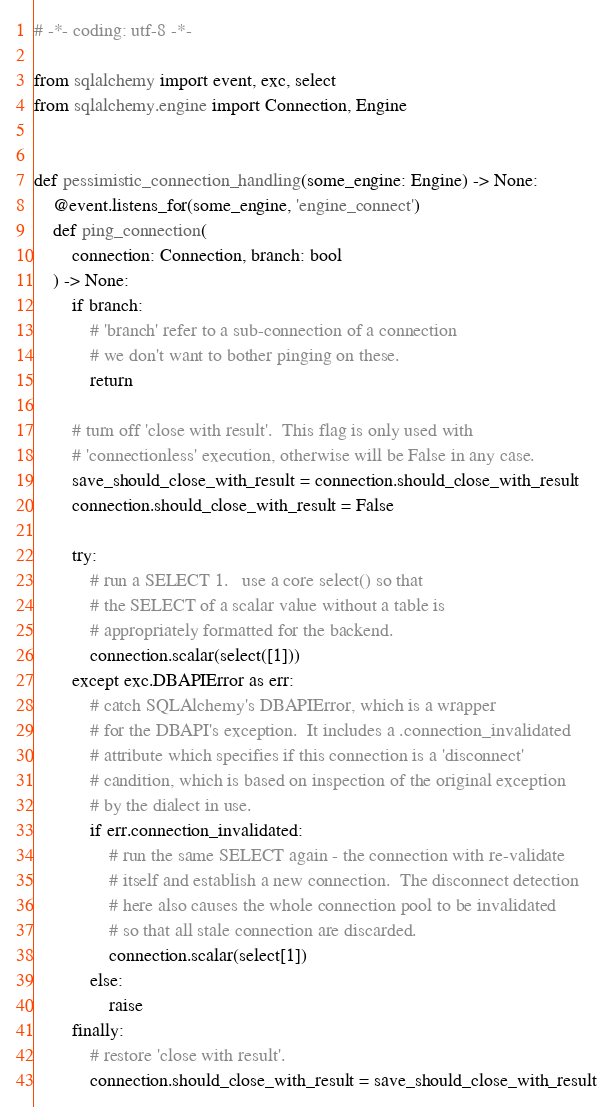<code> <loc_0><loc_0><loc_500><loc_500><_Python_># -*- coding: utf-8 -*-

from sqlalchemy import event, exc, select
from sqlalchemy.engine import Connection, Engine


def pessimistic_connection_handling(some_engine: Engine) -> None:
    @event.listens_for(some_engine, 'engine_connect')
    def ping_connection(
        connection: Connection, branch: bool
    ) -> None:
        if branch:
            # 'branch' refer to a sub-connection of a connection
            # we don't want to bother pinging on these.
            return

        # turn off 'close with result'.  This flag is only used with
        # 'connectionless' execution, otherwise will be False in any case.
        save_should_close_with_result = connection.should_close_with_result
        connection.should_close_with_result = False

        try:
            # run a SELECT 1.   use a core select() so that
            # the SELECT of a scalar value without a table is
            # appropriately formatted for the backend.
            connection.scalar(select([1]))
        except exc.DBAPIError as err:
            # catch SQLAlchemy's DBAPIError, which is a wrapper
            # for the DBAPI's exception.  It includes a .connection_invalidated
            # attribute which specifies if this connection is a 'disconnect'
            # candition, which is based on inspection of the original exception
            # by the dialect in use.
            if err.connection_invalidated:
                # run the same SELECT again - the connection with re-validate
                # itself and establish a new connection.  The disconnect detection
                # here also causes the whole connection pool to be invalidated
                # so that all stale connection are discarded.
                connection.scalar(select[1])
            else:
                raise
        finally:
            # restore 'close with result'.
            connection.should_close_with_result = save_should_close_with_result
</code> 